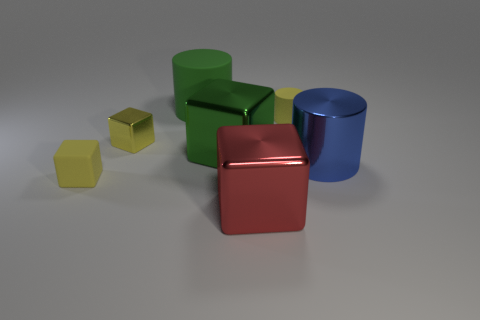There is a green metal object that is the same size as the red shiny cube; what is its shape? cube 